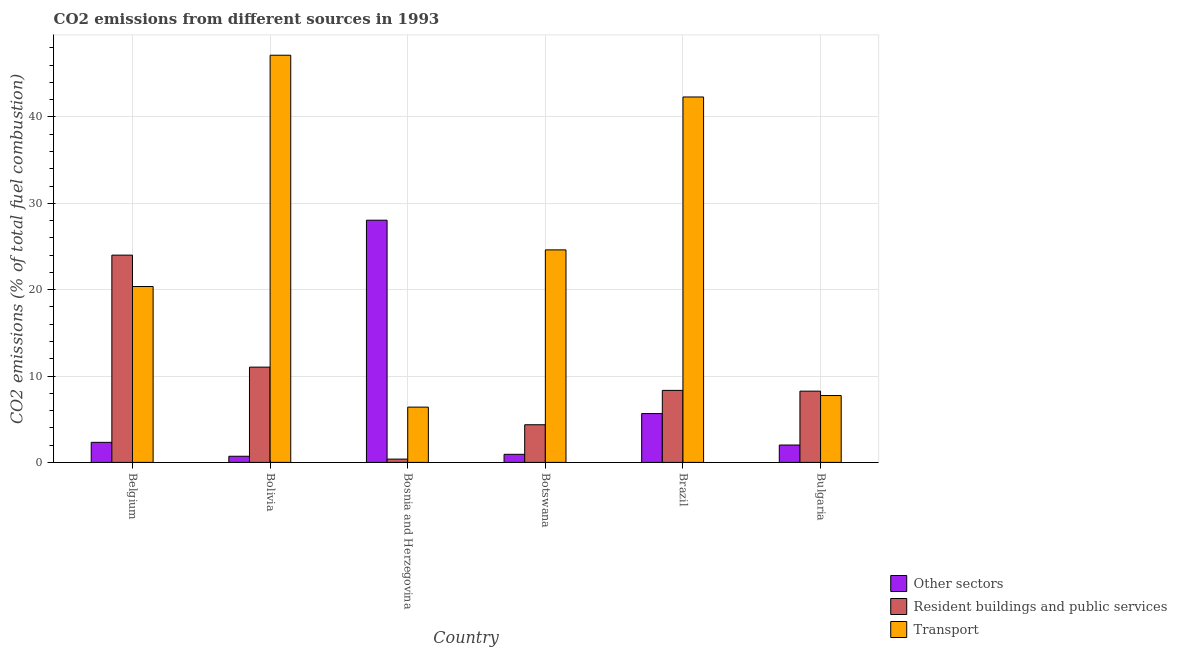How many bars are there on the 5th tick from the left?
Keep it short and to the point. 3. How many bars are there on the 6th tick from the right?
Give a very brief answer. 3. In how many cases, is the number of bars for a given country not equal to the number of legend labels?
Ensure brevity in your answer.  0. What is the percentage of co2 emissions from other sectors in Botswana?
Give a very brief answer. 0.93. Across all countries, what is the maximum percentage of co2 emissions from resident buildings and public services?
Your answer should be compact. 24. Across all countries, what is the minimum percentage of co2 emissions from other sectors?
Ensure brevity in your answer.  0.71. In which country was the percentage of co2 emissions from transport maximum?
Your answer should be very brief. Bolivia. In which country was the percentage of co2 emissions from other sectors minimum?
Provide a short and direct response. Bolivia. What is the total percentage of co2 emissions from other sectors in the graph?
Offer a very short reply. 39.68. What is the difference between the percentage of co2 emissions from other sectors in Brazil and that in Bulgaria?
Keep it short and to the point. 3.64. What is the difference between the percentage of co2 emissions from other sectors in Bolivia and the percentage of co2 emissions from resident buildings and public services in Belgium?
Offer a very short reply. -23.29. What is the average percentage of co2 emissions from resident buildings and public services per country?
Your answer should be compact. 9.39. What is the difference between the percentage of co2 emissions from other sectors and percentage of co2 emissions from resident buildings and public services in Bulgaria?
Your answer should be compact. -6.24. In how many countries, is the percentage of co2 emissions from resident buildings and public services greater than 26 %?
Ensure brevity in your answer.  0. What is the ratio of the percentage of co2 emissions from resident buildings and public services in Belgium to that in Bulgaria?
Offer a very short reply. 2.91. Is the percentage of co2 emissions from transport in Belgium less than that in Botswana?
Give a very brief answer. Yes. Is the difference between the percentage of co2 emissions from other sectors in Bolivia and Botswana greater than the difference between the percentage of co2 emissions from resident buildings and public services in Bolivia and Botswana?
Ensure brevity in your answer.  No. What is the difference between the highest and the second highest percentage of co2 emissions from transport?
Keep it short and to the point. 4.83. What is the difference between the highest and the lowest percentage of co2 emissions from resident buildings and public services?
Your answer should be very brief. 23.62. In how many countries, is the percentage of co2 emissions from other sectors greater than the average percentage of co2 emissions from other sectors taken over all countries?
Your response must be concise. 1. What does the 1st bar from the left in Brazil represents?
Give a very brief answer. Other sectors. What does the 2nd bar from the right in Brazil represents?
Make the answer very short. Resident buildings and public services. How many bars are there?
Make the answer very short. 18. Are the values on the major ticks of Y-axis written in scientific E-notation?
Offer a terse response. No. Does the graph contain grids?
Offer a terse response. Yes. Where does the legend appear in the graph?
Offer a very short reply. Bottom right. How many legend labels are there?
Provide a short and direct response. 3. What is the title of the graph?
Keep it short and to the point. CO2 emissions from different sources in 1993. Does "New Zealand" appear as one of the legend labels in the graph?
Keep it short and to the point. No. What is the label or title of the X-axis?
Make the answer very short. Country. What is the label or title of the Y-axis?
Your response must be concise. CO2 emissions (% of total fuel combustion). What is the CO2 emissions (% of total fuel combustion) in Other sectors in Belgium?
Ensure brevity in your answer.  2.32. What is the CO2 emissions (% of total fuel combustion) in Resident buildings and public services in Belgium?
Offer a very short reply. 24. What is the CO2 emissions (% of total fuel combustion) of Transport in Belgium?
Give a very brief answer. 20.37. What is the CO2 emissions (% of total fuel combustion) in Other sectors in Bolivia?
Your answer should be compact. 0.71. What is the CO2 emissions (% of total fuel combustion) in Resident buildings and public services in Bolivia?
Make the answer very short. 11.03. What is the CO2 emissions (% of total fuel combustion) in Transport in Bolivia?
Keep it short and to the point. 47.15. What is the CO2 emissions (% of total fuel combustion) of Other sectors in Bosnia and Herzegovina?
Make the answer very short. 28.05. What is the CO2 emissions (% of total fuel combustion) in Resident buildings and public services in Bosnia and Herzegovina?
Offer a terse response. 0.38. What is the CO2 emissions (% of total fuel combustion) in Transport in Bosnia and Herzegovina?
Provide a short and direct response. 6.4. What is the CO2 emissions (% of total fuel combustion) of Other sectors in Botswana?
Your response must be concise. 0.93. What is the CO2 emissions (% of total fuel combustion) of Resident buildings and public services in Botswana?
Offer a very short reply. 4.36. What is the CO2 emissions (% of total fuel combustion) in Transport in Botswana?
Provide a short and direct response. 24.61. What is the CO2 emissions (% of total fuel combustion) in Other sectors in Brazil?
Your answer should be compact. 5.65. What is the CO2 emissions (% of total fuel combustion) in Resident buildings and public services in Brazil?
Your response must be concise. 8.34. What is the CO2 emissions (% of total fuel combustion) in Transport in Brazil?
Provide a succinct answer. 42.32. What is the CO2 emissions (% of total fuel combustion) of Other sectors in Bulgaria?
Keep it short and to the point. 2.01. What is the CO2 emissions (% of total fuel combustion) in Resident buildings and public services in Bulgaria?
Keep it short and to the point. 8.25. What is the CO2 emissions (% of total fuel combustion) of Transport in Bulgaria?
Your answer should be compact. 7.74. Across all countries, what is the maximum CO2 emissions (% of total fuel combustion) of Other sectors?
Provide a succinct answer. 28.05. Across all countries, what is the maximum CO2 emissions (% of total fuel combustion) of Resident buildings and public services?
Your answer should be compact. 24. Across all countries, what is the maximum CO2 emissions (% of total fuel combustion) in Transport?
Provide a succinct answer. 47.15. Across all countries, what is the minimum CO2 emissions (% of total fuel combustion) in Other sectors?
Provide a short and direct response. 0.71. Across all countries, what is the minimum CO2 emissions (% of total fuel combustion) of Resident buildings and public services?
Provide a succinct answer. 0.38. Across all countries, what is the minimum CO2 emissions (% of total fuel combustion) of Transport?
Ensure brevity in your answer.  6.4. What is the total CO2 emissions (% of total fuel combustion) of Other sectors in the graph?
Provide a short and direct response. 39.68. What is the total CO2 emissions (% of total fuel combustion) in Resident buildings and public services in the graph?
Ensure brevity in your answer.  56.37. What is the total CO2 emissions (% of total fuel combustion) of Transport in the graph?
Ensure brevity in your answer.  148.6. What is the difference between the CO2 emissions (% of total fuel combustion) in Other sectors in Belgium and that in Bolivia?
Give a very brief answer. 1.61. What is the difference between the CO2 emissions (% of total fuel combustion) in Resident buildings and public services in Belgium and that in Bolivia?
Your response must be concise. 12.97. What is the difference between the CO2 emissions (% of total fuel combustion) in Transport in Belgium and that in Bolivia?
Your answer should be compact. -26.79. What is the difference between the CO2 emissions (% of total fuel combustion) of Other sectors in Belgium and that in Bosnia and Herzegovina?
Your answer should be very brief. -25.73. What is the difference between the CO2 emissions (% of total fuel combustion) of Resident buildings and public services in Belgium and that in Bosnia and Herzegovina?
Provide a short and direct response. 23.62. What is the difference between the CO2 emissions (% of total fuel combustion) in Transport in Belgium and that in Bosnia and Herzegovina?
Your answer should be compact. 13.97. What is the difference between the CO2 emissions (% of total fuel combustion) in Other sectors in Belgium and that in Botswana?
Your answer should be compact. 1.39. What is the difference between the CO2 emissions (% of total fuel combustion) in Resident buildings and public services in Belgium and that in Botswana?
Offer a very short reply. 19.64. What is the difference between the CO2 emissions (% of total fuel combustion) in Transport in Belgium and that in Botswana?
Offer a terse response. -4.24. What is the difference between the CO2 emissions (% of total fuel combustion) of Other sectors in Belgium and that in Brazil?
Your answer should be compact. -3.33. What is the difference between the CO2 emissions (% of total fuel combustion) in Resident buildings and public services in Belgium and that in Brazil?
Provide a succinct answer. 15.66. What is the difference between the CO2 emissions (% of total fuel combustion) in Transport in Belgium and that in Brazil?
Ensure brevity in your answer.  -21.95. What is the difference between the CO2 emissions (% of total fuel combustion) of Other sectors in Belgium and that in Bulgaria?
Ensure brevity in your answer.  0.31. What is the difference between the CO2 emissions (% of total fuel combustion) of Resident buildings and public services in Belgium and that in Bulgaria?
Provide a succinct answer. 15.75. What is the difference between the CO2 emissions (% of total fuel combustion) of Transport in Belgium and that in Bulgaria?
Provide a short and direct response. 12.63. What is the difference between the CO2 emissions (% of total fuel combustion) in Other sectors in Bolivia and that in Bosnia and Herzegovina?
Provide a short and direct response. -27.34. What is the difference between the CO2 emissions (% of total fuel combustion) in Resident buildings and public services in Bolivia and that in Bosnia and Herzegovina?
Offer a very short reply. 10.65. What is the difference between the CO2 emissions (% of total fuel combustion) in Transport in Bolivia and that in Bosnia and Herzegovina?
Offer a very short reply. 40.75. What is the difference between the CO2 emissions (% of total fuel combustion) in Other sectors in Bolivia and that in Botswana?
Provide a succinct answer. -0.22. What is the difference between the CO2 emissions (% of total fuel combustion) in Resident buildings and public services in Bolivia and that in Botswana?
Your answer should be very brief. 6.67. What is the difference between the CO2 emissions (% of total fuel combustion) of Transport in Bolivia and that in Botswana?
Make the answer very short. 22.54. What is the difference between the CO2 emissions (% of total fuel combustion) in Other sectors in Bolivia and that in Brazil?
Make the answer very short. -4.94. What is the difference between the CO2 emissions (% of total fuel combustion) of Resident buildings and public services in Bolivia and that in Brazil?
Your response must be concise. 2.69. What is the difference between the CO2 emissions (% of total fuel combustion) of Transport in Bolivia and that in Brazil?
Provide a short and direct response. 4.83. What is the difference between the CO2 emissions (% of total fuel combustion) of Other sectors in Bolivia and that in Bulgaria?
Give a very brief answer. -1.3. What is the difference between the CO2 emissions (% of total fuel combustion) of Resident buildings and public services in Bolivia and that in Bulgaria?
Give a very brief answer. 2.78. What is the difference between the CO2 emissions (% of total fuel combustion) of Transport in Bolivia and that in Bulgaria?
Keep it short and to the point. 39.41. What is the difference between the CO2 emissions (% of total fuel combustion) in Other sectors in Bosnia and Herzegovina and that in Botswana?
Your response must be concise. 27.11. What is the difference between the CO2 emissions (% of total fuel combustion) in Resident buildings and public services in Bosnia and Herzegovina and that in Botswana?
Offer a terse response. -3.98. What is the difference between the CO2 emissions (% of total fuel combustion) in Transport in Bosnia and Herzegovina and that in Botswana?
Your response must be concise. -18.21. What is the difference between the CO2 emissions (% of total fuel combustion) of Other sectors in Bosnia and Herzegovina and that in Brazil?
Your answer should be very brief. 22.4. What is the difference between the CO2 emissions (% of total fuel combustion) in Resident buildings and public services in Bosnia and Herzegovina and that in Brazil?
Provide a short and direct response. -7.96. What is the difference between the CO2 emissions (% of total fuel combustion) of Transport in Bosnia and Herzegovina and that in Brazil?
Your response must be concise. -35.92. What is the difference between the CO2 emissions (% of total fuel combustion) in Other sectors in Bosnia and Herzegovina and that in Bulgaria?
Provide a succinct answer. 26.04. What is the difference between the CO2 emissions (% of total fuel combustion) in Resident buildings and public services in Bosnia and Herzegovina and that in Bulgaria?
Make the answer very short. -7.87. What is the difference between the CO2 emissions (% of total fuel combustion) of Transport in Bosnia and Herzegovina and that in Bulgaria?
Your response must be concise. -1.34. What is the difference between the CO2 emissions (% of total fuel combustion) of Other sectors in Botswana and that in Brazil?
Make the answer very short. -4.72. What is the difference between the CO2 emissions (% of total fuel combustion) in Resident buildings and public services in Botswana and that in Brazil?
Ensure brevity in your answer.  -3.98. What is the difference between the CO2 emissions (% of total fuel combustion) of Transport in Botswana and that in Brazil?
Your answer should be very brief. -17.71. What is the difference between the CO2 emissions (% of total fuel combustion) in Other sectors in Botswana and that in Bulgaria?
Give a very brief answer. -1.08. What is the difference between the CO2 emissions (% of total fuel combustion) in Resident buildings and public services in Botswana and that in Bulgaria?
Provide a succinct answer. -3.89. What is the difference between the CO2 emissions (% of total fuel combustion) in Transport in Botswana and that in Bulgaria?
Provide a short and direct response. 16.87. What is the difference between the CO2 emissions (% of total fuel combustion) in Other sectors in Brazil and that in Bulgaria?
Offer a terse response. 3.64. What is the difference between the CO2 emissions (% of total fuel combustion) of Resident buildings and public services in Brazil and that in Bulgaria?
Make the answer very short. 0.09. What is the difference between the CO2 emissions (% of total fuel combustion) of Transport in Brazil and that in Bulgaria?
Provide a succinct answer. 34.58. What is the difference between the CO2 emissions (% of total fuel combustion) of Other sectors in Belgium and the CO2 emissions (% of total fuel combustion) of Resident buildings and public services in Bolivia?
Provide a short and direct response. -8.71. What is the difference between the CO2 emissions (% of total fuel combustion) in Other sectors in Belgium and the CO2 emissions (% of total fuel combustion) in Transport in Bolivia?
Give a very brief answer. -44.83. What is the difference between the CO2 emissions (% of total fuel combustion) in Resident buildings and public services in Belgium and the CO2 emissions (% of total fuel combustion) in Transport in Bolivia?
Offer a terse response. -23.15. What is the difference between the CO2 emissions (% of total fuel combustion) in Other sectors in Belgium and the CO2 emissions (% of total fuel combustion) in Resident buildings and public services in Bosnia and Herzegovina?
Offer a terse response. 1.94. What is the difference between the CO2 emissions (% of total fuel combustion) of Other sectors in Belgium and the CO2 emissions (% of total fuel combustion) of Transport in Bosnia and Herzegovina?
Provide a short and direct response. -4.08. What is the difference between the CO2 emissions (% of total fuel combustion) of Resident buildings and public services in Belgium and the CO2 emissions (% of total fuel combustion) of Transport in Bosnia and Herzegovina?
Offer a terse response. 17.6. What is the difference between the CO2 emissions (% of total fuel combustion) in Other sectors in Belgium and the CO2 emissions (% of total fuel combustion) in Resident buildings and public services in Botswana?
Make the answer very short. -2.04. What is the difference between the CO2 emissions (% of total fuel combustion) in Other sectors in Belgium and the CO2 emissions (% of total fuel combustion) in Transport in Botswana?
Your answer should be compact. -22.29. What is the difference between the CO2 emissions (% of total fuel combustion) of Resident buildings and public services in Belgium and the CO2 emissions (% of total fuel combustion) of Transport in Botswana?
Offer a terse response. -0.61. What is the difference between the CO2 emissions (% of total fuel combustion) in Other sectors in Belgium and the CO2 emissions (% of total fuel combustion) in Resident buildings and public services in Brazil?
Make the answer very short. -6.02. What is the difference between the CO2 emissions (% of total fuel combustion) in Other sectors in Belgium and the CO2 emissions (% of total fuel combustion) in Transport in Brazil?
Your answer should be compact. -40. What is the difference between the CO2 emissions (% of total fuel combustion) in Resident buildings and public services in Belgium and the CO2 emissions (% of total fuel combustion) in Transport in Brazil?
Your response must be concise. -18.32. What is the difference between the CO2 emissions (% of total fuel combustion) of Other sectors in Belgium and the CO2 emissions (% of total fuel combustion) of Resident buildings and public services in Bulgaria?
Make the answer very short. -5.93. What is the difference between the CO2 emissions (% of total fuel combustion) of Other sectors in Belgium and the CO2 emissions (% of total fuel combustion) of Transport in Bulgaria?
Provide a short and direct response. -5.42. What is the difference between the CO2 emissions (% of total fuel combustion) in Resident buildings and public services in Belgium and the CO2 emissions (% of total fuel combustion) in Transport in Bulgaria?
Keep it short and to the point. 16.26. What is the difference between the CO2 emissions (% of total fuel combustion) of Other sectors in Bolivia and the CO2 emissions (% of total fuel combustion) of Resident buildings and public services in Bosnia and Herzegovina?
Provide a short and direct response. 0.33. What is the difference between the CO2 emissions (% of total fuel combustion) in Other sectors in Bolivia and the CO2 emissions (% of total fuel combustion) in Transport in Bosnia and Herzegovina?
Keep it short and to the point. -5.69. What is the difference between the CO2 emissions (% of total fuel combustion) in Resident buildings and public services in Bolivia and the CO2 emissions (% of total fuel combustion) in Transport in Bosnia and Herzegovina?
Give a very brief answer. 4.63. What is the difference between the CO2 emissions (% of total fuel combustion) of Other sectors in Bolivia and the CO2 emissions (% of total fuel combustion) of Resident buildings and public services in Botswana?
Ensure brevity in your answer.  -3.65. What is the difference between the CO2 emissions (% of total fuel combustion) in Other sectors in Bolivia and the CO2 emissions (% of total fuel combustion) in Transport in Botswana?
Ensure brevity in your answer.  -23.9. What is the difference between the CO2 emissions (% of total fuel combustion) in Resident buildings and public services in Bolivia and the CO2 emissions (% of total fuel combustion) in Transport in Botswana?
Your response must be concise. -13.58. What is the difference between the CO2 emissions (% of total fuel combustion) of Other sectors in Bolivia and the CO2 emissions (% of total fuel combustion) of Resident buildings and public services in Brazil?
Your answer should be compact. -7.63. What is the difference between the CO2 emissions (% of total fuel combustion) in Other sectors in Bolivia and the CO2 emissions (% of total fuel combustion) in Transport in Brazil?
Provide a succinct answer. -41.61. What is the difference between the CO2 emissions (% of total fuel combustion) in Resident buildings and public services in Bolivia and the CO2 emissions (% of total fuel combustion) in Transport in Brazil?
Keep it short and to the point. -31.29. What is the difference between the CO2 emissions (% of total fuel combustion) in Other sectors in Bolivia and the CO2 emissions (% of total fuel combustion) in Resident buildings and public services in Bulgaria?
Your response must be concise. -7.54. What is the difference between the CO2 emissions (% of total fuel combustion) in Other sectors in Bolivia and the CO2 emissions (% of total fuel combustion) in Transport in Bulgaria?
Offer a very short reply. -7.03. What is the difference between the CO2 emissions (% of total fuel combustion) in Resident buildings and public services in Bolivia and the CO2 emissions (% of total fuel combustion) in Transport in Bulgaria?
Your answer should be very brief. 3.29. What is the difference between the CO2 emissions (% of total fuel combustion) in Other sectors in Bosnia and Herzegovina and the CO2 emissions (% of total fuel combustion) in Resident buildings and public services in Botswana?
Offer a terse response. 23.69. What is the difference between the CO2 emissions (% of total fuel combustion) in Other sectors in Bosnia and Herzegovina and the CO2 emissions (% of total fuel combustion) in Transport in Botswana?
Make the answer very short. 3.44. What is the difference between the CO2 emissions (% of total fuel combustion) of Resident buildings and public services in Bosnia and Herzegovina and the CO2 emissions (% of total fuel combustion) of Transport in Botswana?
Your answer should be compact. -24.23. What is the difference between the CO2 emissions (% of total fuel combustion) of Other sectors in Bosnia and Herzegovina and the CO2 emissions (% of total fuel combustion) of Resident buildings and public services in Brazil?
Offer a very short reply. 19.71. What is the difference between the CO2 emissions (% of total fuel combustion) in Other sectors in Bosnia and Herzegovina and the CO2 emissions (% of total fuel combustion) in Transport in Brazil?
Offer a very short reply. -14.27. What is the difference between the CO2 emissions (% of total fuel combustion) in Resident buildings and public services in Bosnia and Herzegovina and the CO2 emissions (% of total fuel combustion) in Transport in Brazil?
Make the answer very short. -41.94. What is the difference between the CO2 emissions (% of total fuel combustion) in Other sectors in Bosnia and Herzegovina and the CO2 emissions (% of total fuel combustion) in Resident buildings and public services in Bulgaria?
Provide a short and direct response. 19.8. What is the difference between the CO2 emissions (% of total fuel combustion) in Other sectors in Bosnia and Herzegovina and the CO2 emissions (% of total fuel combustion) in Transport in Bulgaria?
Your response must be concise. 20.31. What is the difference between the CO2 emissions (% of total fuel combustion) in Resident buildings and public services in Bosnia and Herzegovina and the CO2 emissions (% of total fuel combustion) in Transport in Bulgaria?
Keep it short and to the point. -7.36. What is the difference between the CO2 emissions (% of total fuel combustion) in Other sectors in Botswana and the CO2 emissions (% of total fuel combustion) in Resident buildings and public services in Brazil?
Your answer should be compact. -7.41. What is the difference between the CO2 emissions (% of total fuel combustion) of Other sectors in Botswana and the CO2 emissions (% of total fuel combustion) of Transport in Brazil?
Provide a succinct answer. -41.38. What is the difference between the CO2 emissions (% of total fuel combustion) of Resident buildings and public services in Botswana and the CO2 emissions (% of total fuel combustion) of Transport in Brazil?
Offer a very short reply. -37.96. What is the difference between the CO2 emissions (% of total fuel combustion) in Other sectors in Botswana and the CO2 emissions (% of total fuel combustion) in Resident buildings and public services in Bulgaria?
Ensure brevity in your answer.  -7.32. What is the difference between the CO2 emissions (% of total fuel combustion) in Other sectors in Botswana and the CO2 emissions (% of total fuel combustion) in Transport in Bulgaria?
Your answer should be very brief. -6.81. What is the difference between the CO2 emissions (% of total fuel combustion) in Resident buildings and public services in Botswana and the CO2 emissions (% of total fuel combustion) in Transport in Bulgaria?
Your response must be concise. -3.38. What is the difference between the CO2 emissions (% of total fuel combustion) of Other sectors in Brazil and the CO2 emissions (% of total fuel combustion) of Resident buildings and public services in Bulgaria?
Make the answer very short. -2.6. What is the difference between the CO2 emissions (% of total fuel combustion) of Other sectors in Brazil and the CO2 emissions (% of total fuel combustion) of Transport in Bulgaria?
Keep it short and to the point. -2.09. What is the difference between the CO2 emissions (% of total fuel combustion) of Resident buildings and public services in Brazil and the CO2 emissions (% of total fuel combustion) of Transport in Bulgaria?
Your answer should be compact. 0.6. What is the average CO2 emissions (% of total fuel combustion) of Other sectors per country?
Offer a very short reply. 6.61. What is the average CO2 emissions (% of total fuel combustion) in Resident buildings and public services per country?
Ensure brevity in your answer.  9.39. What is the average CO2 emissions (% of total fuel combustion) of Transport per country?
Ensure brevity in your answer.  24.77. What is the difference between the CO2 emissions (% of total fuel combustion) of Other sectors and CO2 emissions (% of total fuel combustion) of Resident buildings and public services in Belgium?
Keep it short and to the point. -21.68. What is the difference between the CO2 emissions (% of total fuel combustion) in Other sectors and CO2 emissions (% of total fuel combustion) in Transport in Belgium?
Offer a terse response. -18.05. What is the difference between the CO2 emissions (% of total fuel combustion) in Resident buildings and public services and CO2 emissions (% of total fuel combustion) in Transport in Belgium?
Your answer should be very brief. 3.63. What is the difference between the CO2 emissions (% of total fuel combustion) of Other sectors and CO2 emissions (% of total fuel combustion) of Resident buildings and public services in Bolivia?
Offer a terse response. -10.32. What is the difference between the CO2 emissions (% of total fuel combustion) of Other sectors and CO2 emissions (% of total fuel combustion) of Transport in Bolivia?
Ensure brevity in your answer.  -46.44. What is the difference between the CO2 emissions (% of total fuel combustion) of Resident buildings and public services and CO2 emissions (% of total fuel combustion) of Transport in Bolivia?
Keep it short and to the point. -36.12. What is the difference between the CO2 emissions (% of total fuel combustion) of Other sectors and CO2 emissions (% of total fuel combustion) of Resident buildings and public services in Bosnia and Herzegovina?
Provide a succinct answer. 27.67. What is the difference between the CO2 emissions (% of total fuel combustion) of Other sectors and CO2 emissions (% of total fuel combustion) of Transport in Bosnia and Herzegovina?
Your answer should be compact. 21.65. What is the difference between the CO2 emissions (% of total fuel combustion) of Resident buildings and public services and CO2 emissions (% of total fuel combustion) of Transport in Bosnia and Herzegovina?
Your response must be concise. -6.02. What is the difference between the CO2 emissions (% of total fuel combustion) of Other sectors and CO2 emissions (% of total fuel combustion) of Resident buildings and public services in Botswana?
Provide a succinct answer. -3.43. What is the difference between the CO2 emissions (% of total fuel combustion) of Other sectors and CO2 emissions (% of total fuel combustion) of Transport in Botswana?
Provide a succinct answer. -23.68. What is the difference between the CO2 emissions (% of total fuel combustion) of Resident buildings and public services and CO2 emissions (% of total fuel combustion) of Transport in Botswana?
Give a very brief answer. -20.25. What is the difference between the CO2 emissions (% of total fuel combustion) of Other sectors and CO2 emissions (% of total fuel combustion) of Resident buildings and public services in Brazil?
Ensure brevity in your answer.  -2.69. What is the difference between the CO2 emissions (% of total fuel combustion) in Other sectors and CO2 emissions (% of total fuel combustion) in Transport in Brazil?
Offer a very short reply. -36.67. What is the difference between the CO2 emissions (% of total fuel combustion) in Resident buildings and public services and CO2 emissions (% of total fuel combustion) in Transport in Brazil?
Your response must be concise. -33.98. What is the difference between the CO2 emissions (% of total fuel combustion) of Other sectors and CO2 emissions (% of total fuel combustion) of Resident buildings and public services in Bulgaria?
Your answer should be compact. -6.24. What is the difference between the CO2 emissions (% of total fuel combustion) in Other sectors and CO2 emissions (% of total fuel combustion) in Transport in Bulgaria?
Keep it short and to the point. -5.73. What is the difference between the CO2 emissions (% of total fuel combustion) in Resident buildings and public services and CO2 emissions (% of total fuel combustion) in Transport in Bulgaria?
Provide a short and direct response. 0.51. What is the ratio of the CO2 emissions (% of total fuel combustion) in Other sectors in Belgium to that in Bolivia?
Keep it short and to the point. 3.26. What is the ratio of the CO2 emissions (% of total fuel combustion) in Resident buildings and public services in Belgium to that in Bolivia?
Your answer should be very brief. 2.18. What is the ratio of the CO2 emissions (% of total fuel combustion) of Transport in Belgium to that in Bolivia?
Offer a terse response. 0.43. What is the ratio of the CO2 emissions (% of total fuel combustion) of Other sectors in Belgium to that in Bosnia and Herzegovina?
Make the answer very short. 0.08. What is the ratio of the CO2 emissions (% of total fuel combustion) of Resident buildings and public services in Belgium to that in Bosnia and Herzegovina?
Your response must be concise. 62.98. What is the ratio of the CO2 emissions (% of total fuel combustion) in Transport in Belgium to that in Bosnia and Herzegovina?
Ensure brevity in your answer.  3.18. What is the ratio of the CO2 emissions (% of total fuel combustion) in Other sectors in Belgium to that in Botswana?
Ensure brevity in your answer.  2.49. What is the ratio of the CO2 emissions (% of total fuel combustion) in Resident buildings and public services in Belgium to that in Botswana?
Your answer should be compact. 5.5. What is the ratio of the CO2 emissions (% of total fuel combustion) of Transport in Belgium to that in Botswana?
Your answer should be compact. 0.83. What is the ratio of the CO2 emissions (% of total fuel combustion) in Other sectors in Belgium to that in Brazil?
Your answer should be compact. 0.41. What is the ratio of the CO2 emissions (% of total fuel combustion) of Resident buildings and public services in Belgium to that in Brazil?
Keep it short and to the point. 2.88. What is the ratio of the CO2 emissions (% of total fuel combustion) of Transport in Belgium to that in Brazil?
Your response must be concise. 0.48. What is the ratio of the CO2 emissions (% of total fuel combustion) in Other sectors in Belgium to that in Bulgaria?
Offer a terse response. 1.15. What is the ratio of the CO2 emissions (% of total fuel combustion) of Resident buildings and public services in Belgium to that in Bulgaria?
Make the answer very short. 2.91. What is the ratio of the CO2 emissions (% of total fuel combustion) in Transport in Belgium to that in Bulgaria?
Ensure brevity in your answer.  2.63. What is the ratio of the CO2 emissions (% of total fuel combustion) of Other sectors in Bolivia to that in Bosnia and Herzegovina?
Provide a succinct answer. 0.03. What is the ratio of the CO2 emissions (% of total fuel combustion) in Resident buildings and public services in Bolivia to that in Bosnia and Herzegovina?
Provide a succinct answer. 28.95. What is the ratio of the CO2 emissions (% of total fuel combustion) of Transport in Bolivia to that in Bosnia and Herzegovina?
Your answer should be very brief. 7.36. What is the ratio of the CO2 emissions (% of total fuel combustion) in Other sectors in Bolivia to that in Botswana?
Provide a short and direct response. 0.76. What is the ratio of the CO2 emissions (% of total fuel combustion) of Resident buildings and public services in Bolivia to that in Botswana?
Provide a short and direct response. 2.53. What is the ratio of the CO2 emissions (% of total fuel combustion) of Transport in Bolivia to that in Botswana?
Your answer should be very brief. 1.92. What is the ratio of the CO2 emissions (% of total fuel combustion) of Other sectors in Bolivia to that in Brazil?
Your answer should be compact. 0.13. What is the ratio of the CO2 emissions (% of total fuel combustion) in Resident buildings and public services in Bolivia to that in Brazil?
Provide a short and direct response. 1.32. What is the ratio of the CO2 emissions (% of total fuel combustion) of Transport in Bolivia to that in Brazil?
Provide a succinct answer. 1.11. What is the ratio of the CO2 emissions (% of total fuel combustion) of Other sectors in Bolivia to that in Bulgaria?
Your response must be concise. 0.35. What is the ratio of the CO2 emissions (% of total fuel combustion) in Resident buildings and public services in Bolivia to that in Bulgaria?
Your answer should be very brief. 1.34. What is the ratio of the CO2 emissions (% of total fuel combustion) in Transport in Bolivia to that in Bulgaria?
Keep it short and to the point. 6.09. What is the ratio of the CO2 emissions (% of total fuel combustion) in Other sectors in Bosnia and Herzegovina to that in Botswana?
Provide a succinct answer. 30.01. What is the ratio of the CO2 emissions (% of total fuel combustion) in Resident buildings and public services in Bosnia and Herzegovina to that in Botswana?
Your answer should be compact. 0.09. What is the ratio of the CO2 emissions (% of total fuel combustion) of Transport in Bosnia and Herzegovina to that in Botswana?
Keep it short and to the point. 0.26. What is the ratio of the CO2 emissions (% of total fuel combustion) in Other sectors in Bosnia and Herzegovina to that in Brazil?
Give a very brief answer. 4.96. What is the ratio of the CO2 emissions (% of total fuel combustion) of Resident buildings and public services in Bosnia and Herzegovina to that in Brazil?
Keep it short and to the point. 0.05. What is the ratio of the CO2 emissions (% of total fuel combustion) in Transport in Bosnia and Herzegovina to that in Brazil?
Give a very brief answer. 0.15. What is the ratio of the CO2 emissions (% of total fuel combustion) in Other sectors in Bosnia and Herzegovina to that in Bulgaria?
Keep it short and to the point. 13.94. What is the ratio of the CO2 emissions (% of total fuel combustion) of Resident buildings and public services in Bosnia and Herzegovina to that in Bulgaria?
Your answer should be compact. 0.05. What is the ratio of the CO2 emissions (% of total fuel combustion) of Transport in Bosnia and Herzegovina to that in Bulgaria?
Offer a terse response. 0.83. What is the ratio of the CO2 emissions (% of total fuel combustion) of Other sectors in Botswana to that in Brazil?
Provide a short and direct response. 0.17. What is the ratio of the CO2 emissions (% of total fuel combustion) of Resident buildings and public services in Botswana to that in Brazil?
Keep it short and to the point. 0.52. What is the ratio of the CO2 emissions (% of total fuel combustion) of Transport in Botswana to that in Brazil?
Make the answer very short. 0.58. What is the ratio of the CO2 emissions (% of total fuel combustion) of Other sectors in Botswana to that in Bulgaria?
Keep it short and to the point. 0.46. What is the ratio of the CO2 emissions (% of total fuel combustion) of Resident buildings and public services in Botswana to that in Bulgaria?
Offer a terse response. 0.53. What is the ratio of the CO2 emissions (% of total fuel combustion) of Transport in Botswana to that in Bulgaria?
Offer a terse response. 3.18. What is the ratio of the CO2 emissions (% of total fuel combustion) in Other sectors in Brazil to that in Bulgaria?
Keep it short and to the point. 2.81. What is the ratio of the CO2 emissions (% of total fuel combustion) in Resident buildings and public services in Brazil to that in Bulgaria?
Keep it short and to the point. 1.01. What is the ratio of the CO2 emissions (% of total fuel combustion) in Transport in Brazil to that in Bulgaria?
Your response must be concise. 5.47. What is the difference between the highest and the second highest CO2 emissions (% of total fuel combustion) of Other sectors?
Provide a succinct answer. 22.4. What is the difference between the highest and the second highest CO2 emissions (% of total fuel combustion) in Resident buildings and public services?
Make the answer very short. 12.97. What is the difference between the highest and the second highest CO2 emissions (% of total fuel combustion) in Transport?
Your answer should be very brief. 4.83. What is the difference between the highest and the lowest CO2 emissions (% of total fuel combustion) in Other sectors?
Make the answer very short. 27.34. What is the difference between the highest and the lowest CO2 emissions (% of total fuel combustion) in Resident buildings and public services?
Keep it short and to the point. 23.62. What is the difference between the highest and the lowest CO2 emissions (% of total fuel combustion) of Transport?
Give a very brief answer. 40.75. 